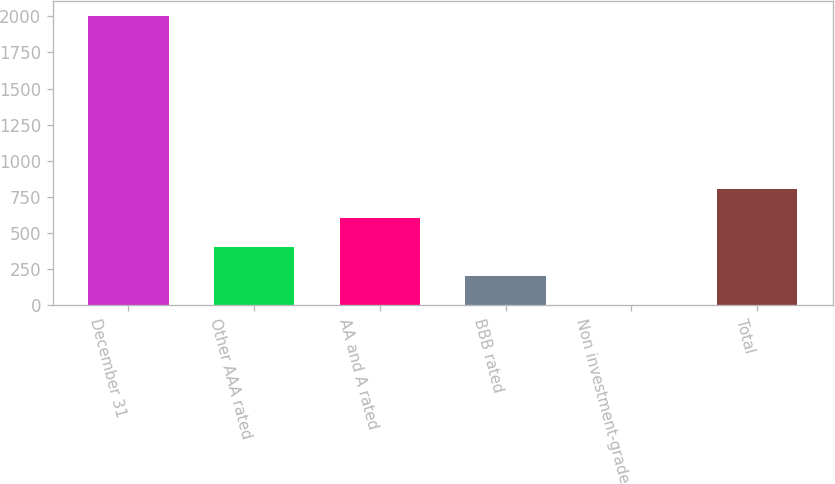Convert chart to OTSL. <chart><loc_0><loc_0><loc_500><loc_500><bar_chart><fcel>December 31<fcel>Other AAA rated<fcel>AA and A rated<fcel>BBB rated<fcel>Non investment-grade<fcel>Total<nl><fcel>2004<fcel>405.6<fcel>605.4<fcel>205.8<fcel>6<fcel>805.2<nl></chart> 